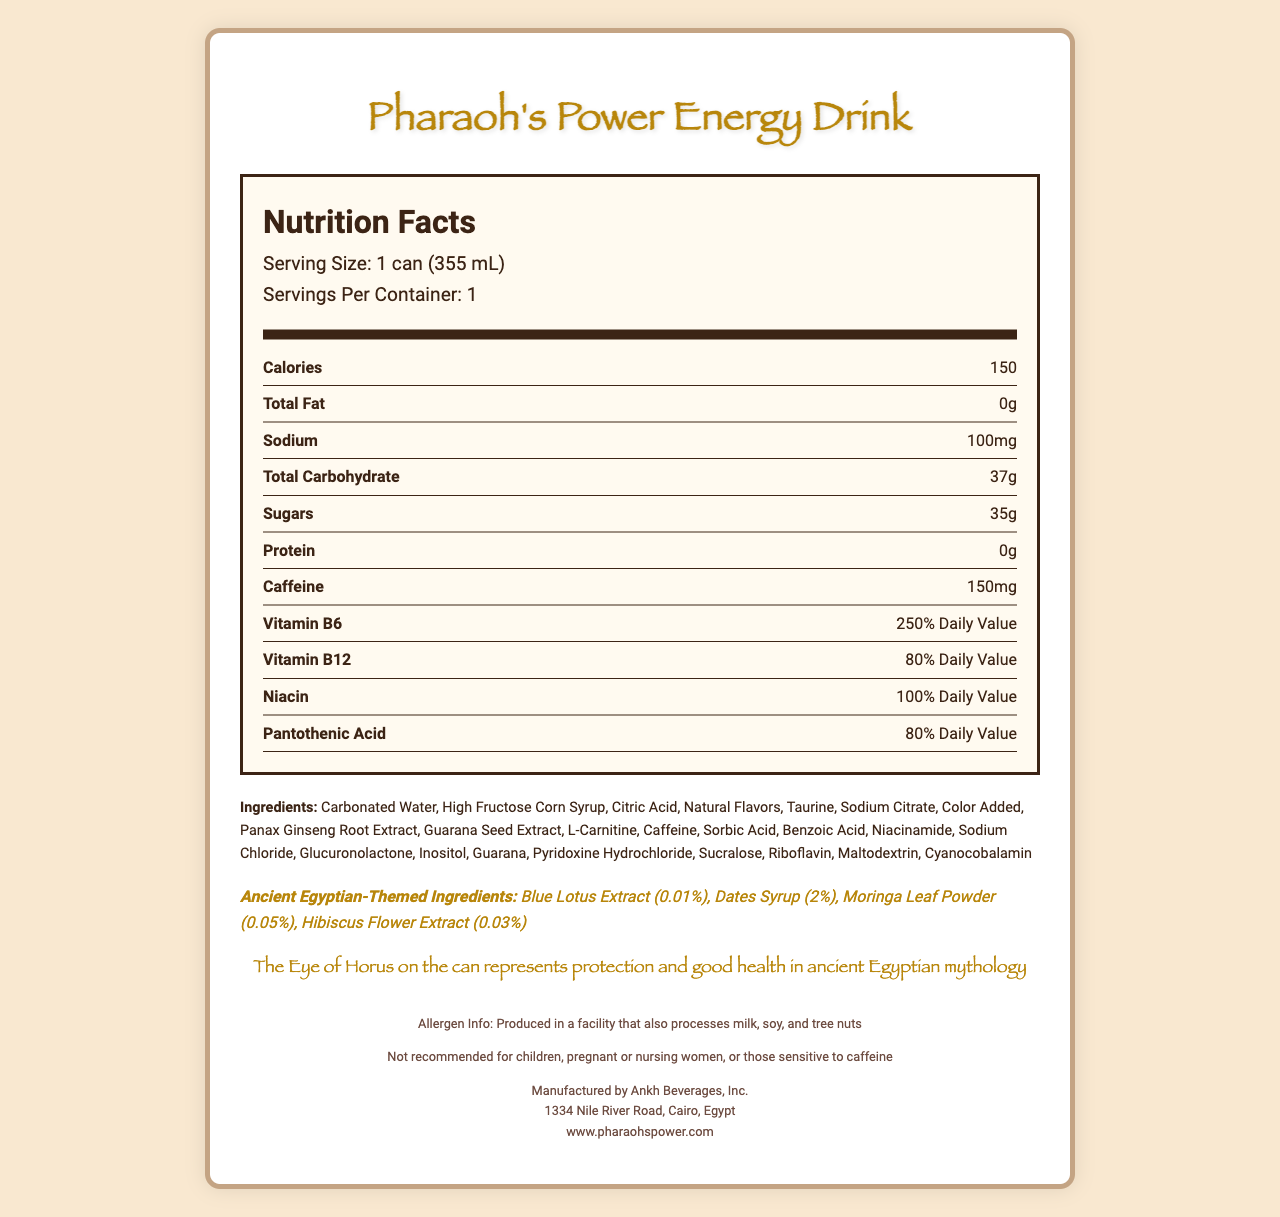what is the serving size? The serving size is explicitly stated as "1 can (355 mL)" in the nutrition facts section.
Answer: 1 can (355 mL) how many calories are in one serving? The number of calories per serving is listed as 150 in the nutrition facts section.
Answer: 150 what percent of daily value of Vitamin B6 is in one serving? The nutrition facts section lists Vitamin B6 as providing 250% of the daily value.
Answer: 250% Daily Value which ingredient has the highest quantity in the list? Ingredients are typically listed in descending order of quantity, so Carbonated Water is the first ingredient and has the highest quantity.
Answer: Carbonated Water what is the name of the manufacturer? The footer of the document clearly states the manufacturer's name as Ankh Beverages, Inc.
Answer: Ankh Beverages, Inc. which of the following ancient Egyptian-themed ingredients are included in the drink? i. Blue Lotus Extract ii. Pomegranate Juice iii. Hibiscus Flower Extract iv. Black Seed Oil Both Blue Lotus Extract and Hibiscus Flower Extract are listed under ancient Egyptian-themed ingredients.
Answer: i and iii how much caffeine is in one serving of the drink? A. 50mg B. 75mg C. 100mg D. 150mg The caffeine content is listed as 150mg in the nutrition facts section.
Answer: D. 150mg what is the main symbolic element used in the packaging design? A. Ankh B. Scarab Beetle C. Eye of Horus D. Pyramid The symbolism note states that the Eye of Horus is on the can and represents protection and good health in ancient Egyptian mythology.
Answer: C. Eye of Horus does this product contain any protein? The protein content is listed as 0g in the nutrition facts section, indicating that it does not contain any protein.
Answer: No what type of consumer is advised not to consume this drink? The disclaimer section advises that the product is not recommended for children, pregnant or nursing women, or those sensitive to caffeine.
Answer: Children, pregnant or nursing women, and those sensitive to caffeine summarize the main highlights of the document. This summary encapsulates the key points about the drink's nutritional content, unique ingredients, symbolic elements, manufacturer, and consumer advice.
Answer: Pharaoh's Power Energy Drink contains 150 calories per can and features unique ancient Egyptian-themed ingredients and symbolism. It has high amounts of Vitamin B6, Vitamin B12, niacin, and pantothenic acid, and provides a significant caffeine boost. The packaging includes the Eye of Horus, symbolizing protection and health. The product is manufactured by Ankh Beverages, Inc., and is not recommended for children, pregnant or nursing women, or those sensitive to caffeine. what is the exact quantity of Moringa Leaf Powder in the drink? The quantity of Moringa Leaf Powder is specifically listed as 0.05% among the ancient Egyptian-themed ingredients.
Answer: 0.05% which ingredient acts as a preservative? Sorbic Acid is commonly used as a preservative and is listed among the ingredients.
Answer: Sorbic Acid does the document specify the exact location of the manufacturer? The footer provides the exact address of the manufacturer.
Answer: Yes, 1334 Nile River Road, Cairo, Egypt can we determine the shelf life of the product from the document? The document does not provide any details regarding the shelf life of the product.
Answer: Not enough information 